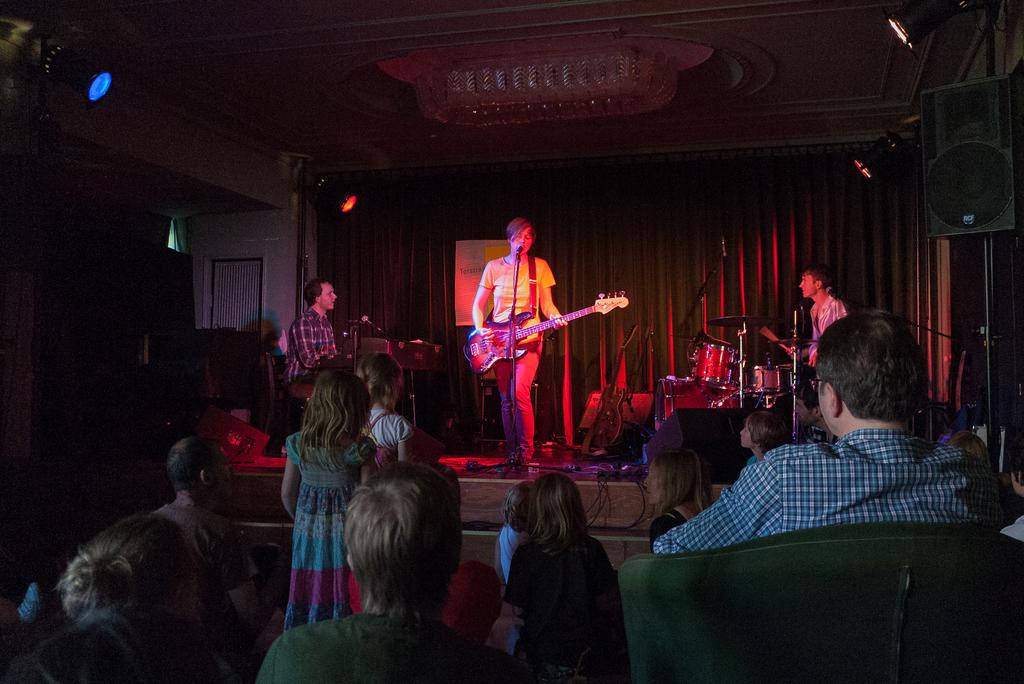What is the main subject of the image? The main subject of the image is a group of people. Can you describe one person in the image? Yes, there is a man standing in the image. What is the man holding in the image? The man is holding a guitar. What type of cookware is the man using to prepare a meal in the image? There is no cookware or meal preparation visible in the image; the man is holding a guitar. What is the man's selection of spades in the image? There are no spades present in the image; the man is holding a guitar. 